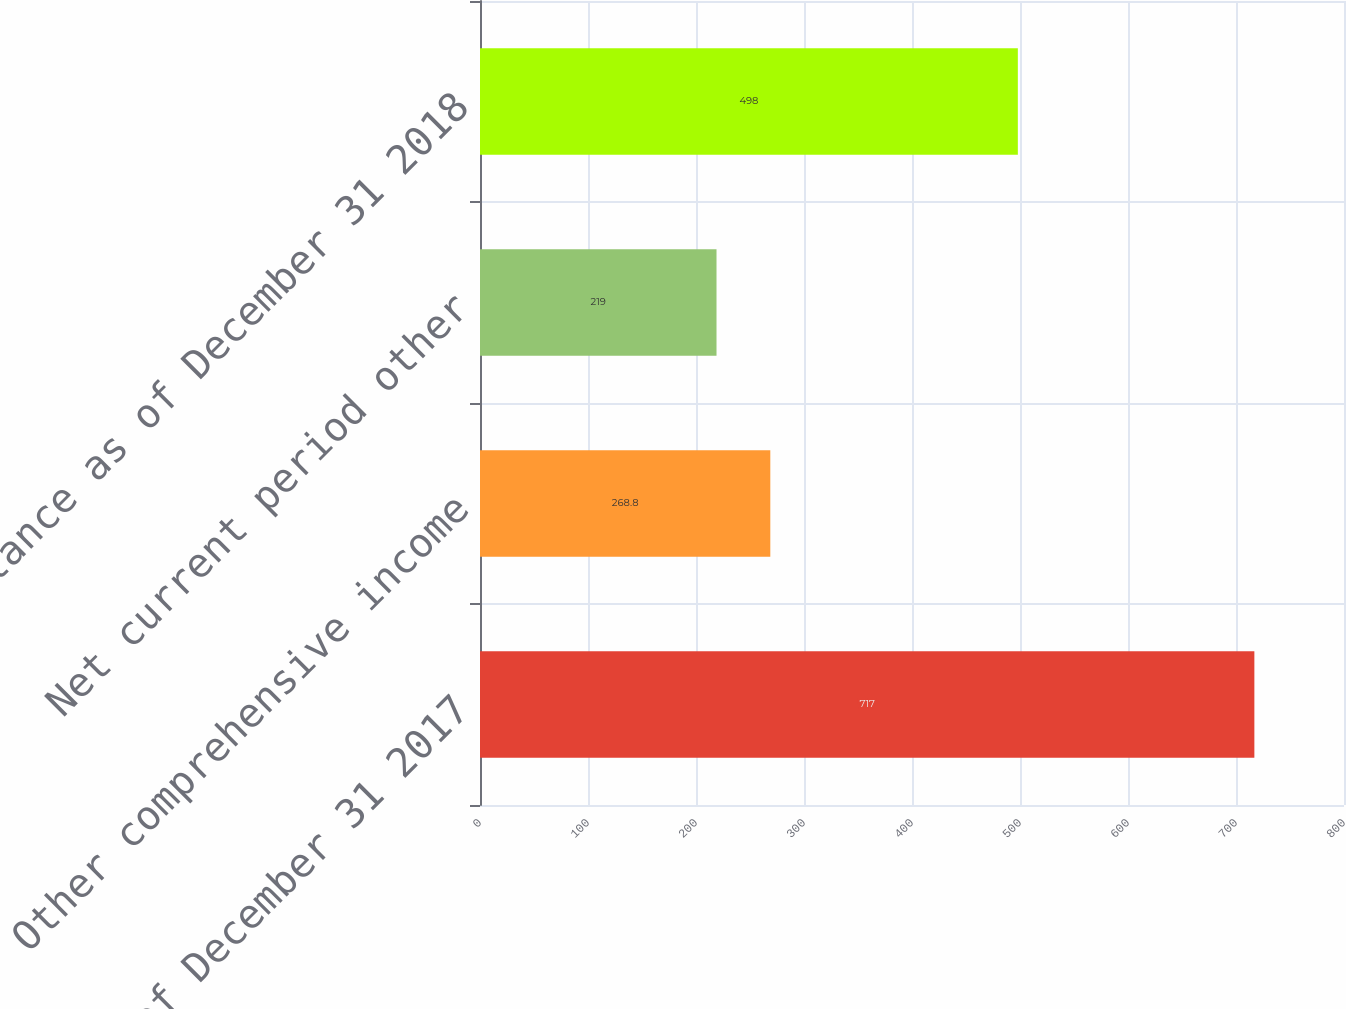<chart> <loc_0><loc_0><loc_500><loc_500><bar_chart><fcel>Balance as of December 31 2017<fcel>Other comprehensive income<fcel>Net current period other<fcel>Balance as of December 31 2018<nl><fcel>717<fcel>268.8<fcel>219<fcel>498<nl></chart> 